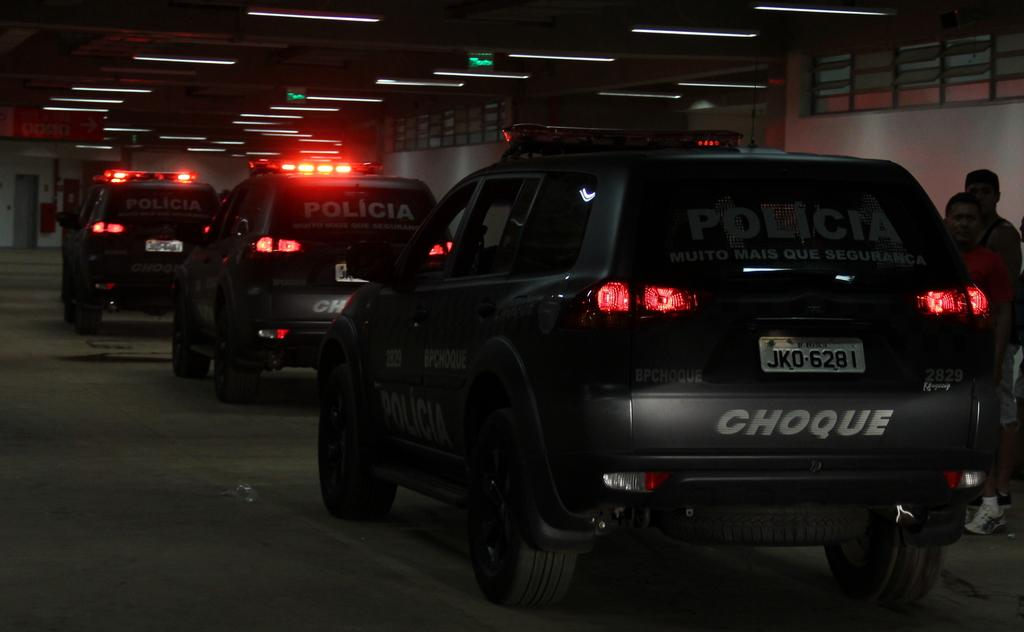<image>
Render a clear and concise summary of the photo. Several police vehicles that say Choque on the back drive through a tunnel. 